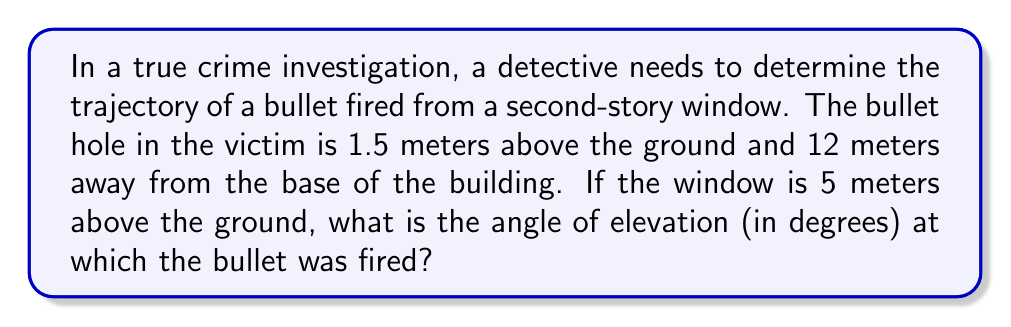Teach me how to tackle this problem. To solve this problem, we can use trigonometric functions, specifically the tangent function. Let's break it down step-by-step:

1. Visualize the scenario:
[asy]
import geometry;

unitsize(1cm);

pair A = (0,0), B = (12,0), C = (0,5), D = (12,1.5);
draw(A--B--D--C--A);
draw(C--D,dashed);

label("Ground", (6,-0.5));
label("Building", (-0.5,2.5));
label("5m", (-0.5,2.5));
label("12m", (6,-0.5));
label("1.5m", (12.5,0.75));
label("θ", (0.5,5), NE);

dot("A", A, SW);
dot("B", B, SE);
dot("C", C, NW);
dot("D", D, NE);
[/asy]

2. Identify the known variables:
   - Height of the window (C): 5 meters
   - Distance from the building to the victim (AB): 12 meters
   - Height of the bullet hole (BD): 1.5 meters

3. Calculate the height difference between the window and the bullet hole:
   $CD = AC - BD = 5 - 1.5 = 3.5$ meters

4. Use the tangent function to find the angle of elevation (θ):
   $\tan(\theta) = \frac{\text{opposite}}{\text{adjacent}} = \frac{CD}{AB} = \frac{3.5}{12}$

5. To find θ, we need to use the inverse tangent (arctan or tan⁻¹) function:
   $\theta = \tan^{-1}\left(\frac{3.5}{12}\right)$

6. Calculate the result:
   $\theta = \tan^{-1}\left(\frac{3.5}{12}\right) \approx 16.26°$

7. Round to two decimal places:
   $\theta \approx 16.26°$
Answer: The angle of elevation at which the bullet was fired is approximately 16.26°. 